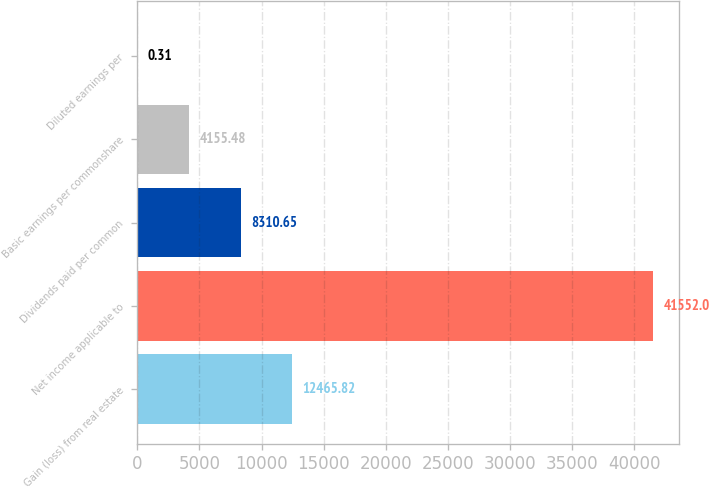<chart> <loc_0><loc_0><loc_500><loc_500><bar_chart><fcel>Gain (loss) from real estate<fcel>Net income applicable to<fcel>Dividends paid per common<fcel>Basic earnings per commonshare<fcel>Diluted earnings per<nl><fcel>12465.8<fcel>41552<fcel>8310.65<fcel>4155.48<fcel>0.31<nl></chart> 